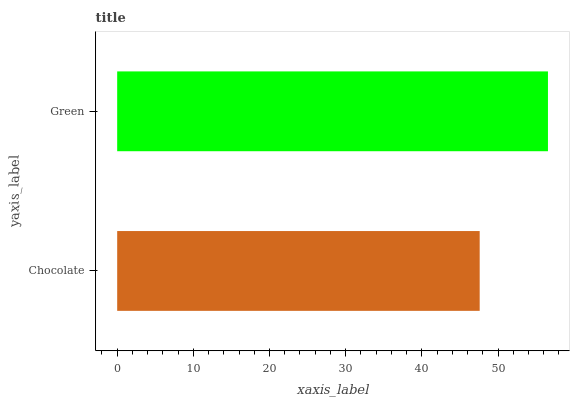Is Chocolate the minimum?
Answer yes or no. Yes. Is Green the maximum?
Answer yes or no. Yes. Is Green the minimum?
Answer yes or no. No. Is Green greater than Chocolate?
Answer yes or no. Yes. Is Chocolate less than Green?
Answer yes or no. Yes. Is Chocolate greater than Green?
Answer yes or no. No. Is Green less than Chocolate?
Answer yes or no. No. Is Green the high median?
Answer yes or no. Yes. Is Chocolate the low median?
Answer yes or no. Yes. Is Chocolate the high median?
Answer yes or no. No. Is Green the low median?
Answer yes or no. No. 